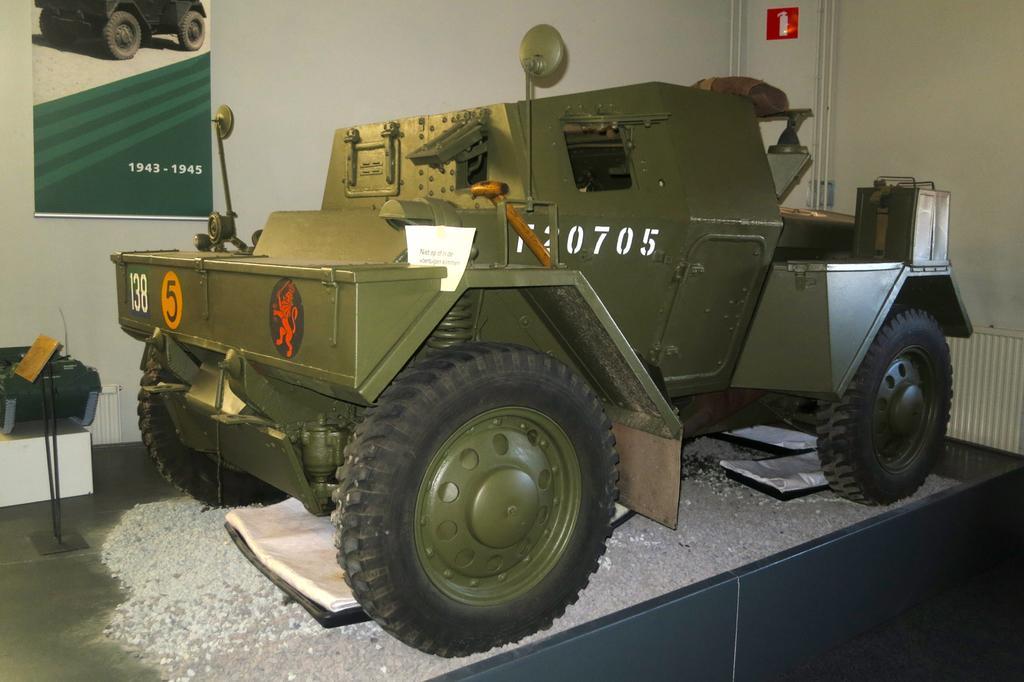Please provide a concise description of this image. In this image in the foreground I can see a truck placed on the surface and the background is the sky. 